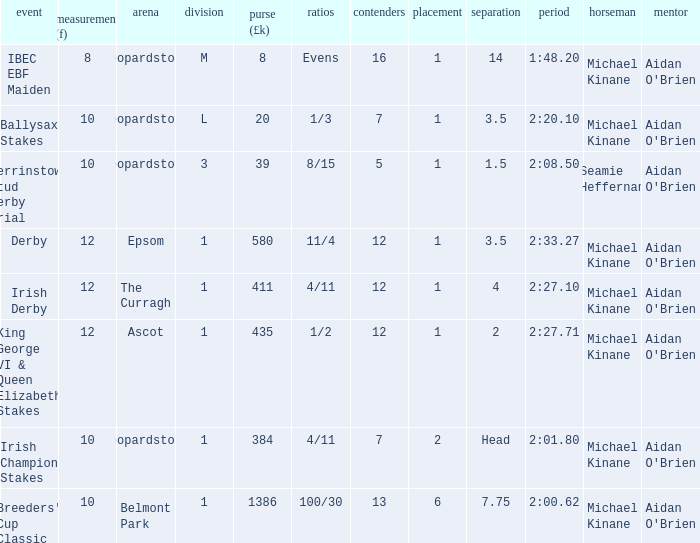Which Class has a Jockey of michael kinane on 2:27.71? 1.0. 